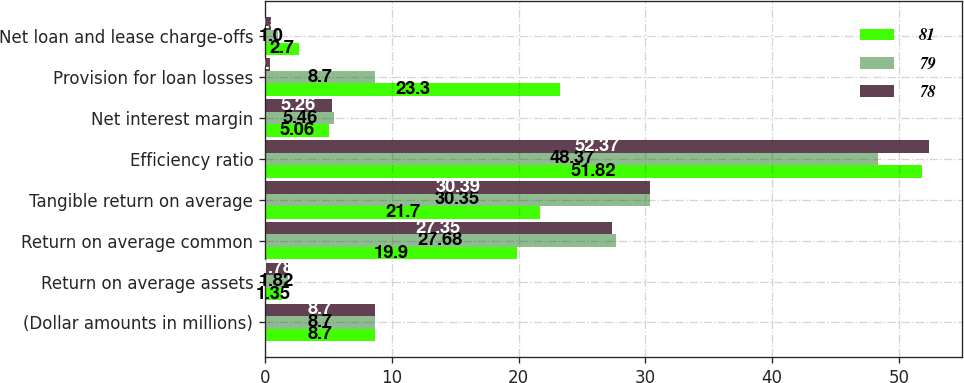Convert chart to OTSL. <chart><loc_0><loc_0><loc_500><loc_500><stacked_bar_chart><ecel><fcel>(Dollar amounts in millions)<fcel>Return on average assets<fcel>Return on average common<fcel>Tangible return on average<fcel>Efficiency ratio<fcel>Net interest margin<fcel>Provision for loan losses<fcel>Net loan and lease charge-offs<nl><fcel>81<fcel>8.7<fcel>1.35<fcel>19.9<fcel>21.7<fcel>51.82<fcel>5.06<fcel>23.3<fcel>2.7<nl><fcel>79<fcel>8.7<fcel>1.82<fcel>27.68<fcel>30.35<fcel>48.37<fcel>5.46<fcel>8.7<fcel>1<nl><fcel>78<fcel>8.7<fcel>1.78<fcel>27.35<fcel>30.39<fcel>52.37<fcel>5.26<fcel>0.4<fcel>0.5<nl></chart> 